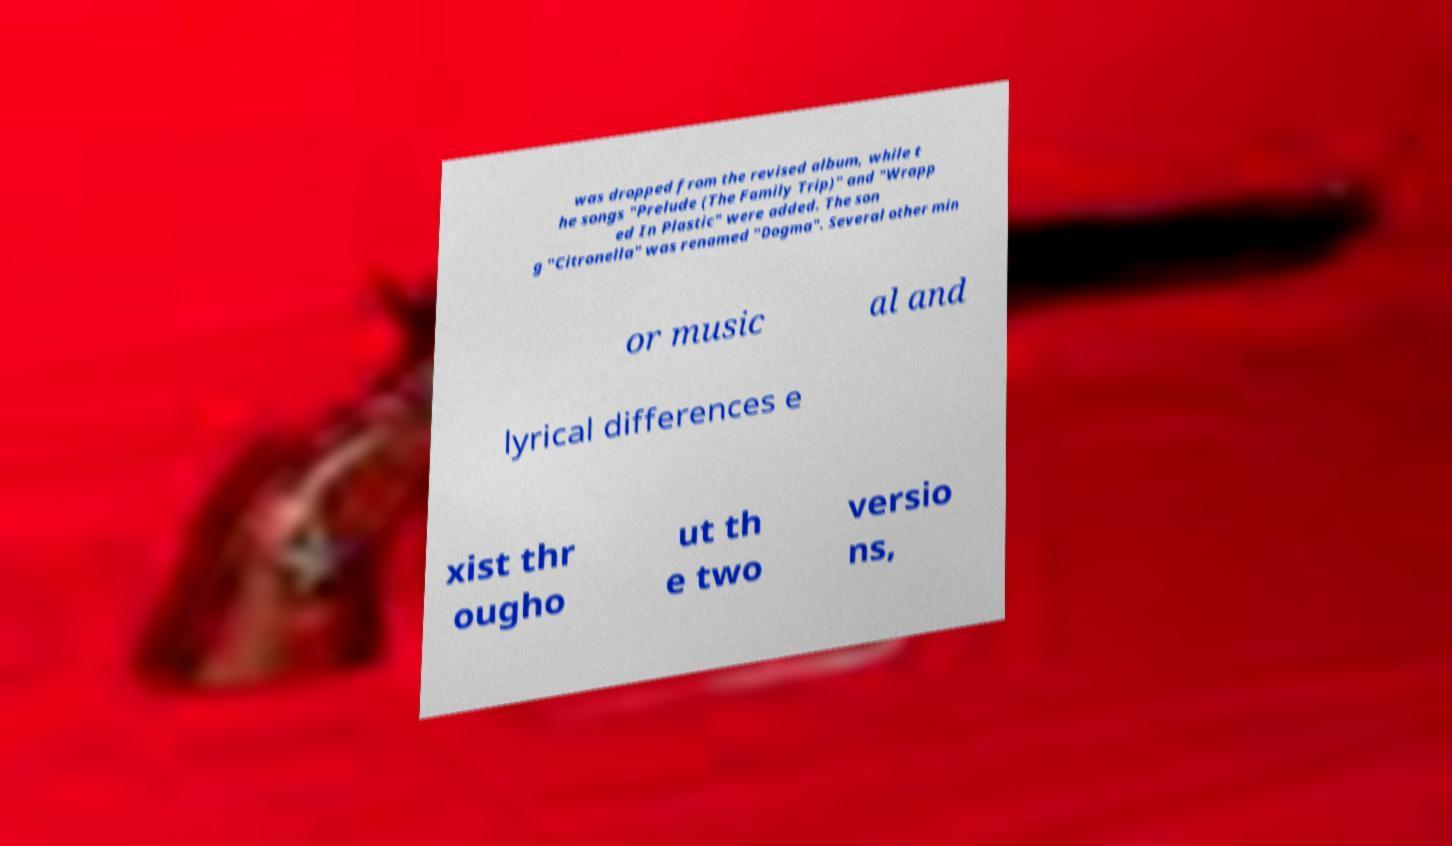I need the written content from this picture converted into text. Can you do that? was dropped from the revised album, while t he songs "Prelude (The Family Trip)" and "Wrapp ed In Plastic" were added. The son g "Citronella" was renamed "Dogma". Several other min or music al and lyrical differences e xist thr ougho ut th e two versio ns, 